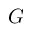Convert formula to latex. <formula><loc_0><loc_0><loc_500><loc_500>G</formula> 